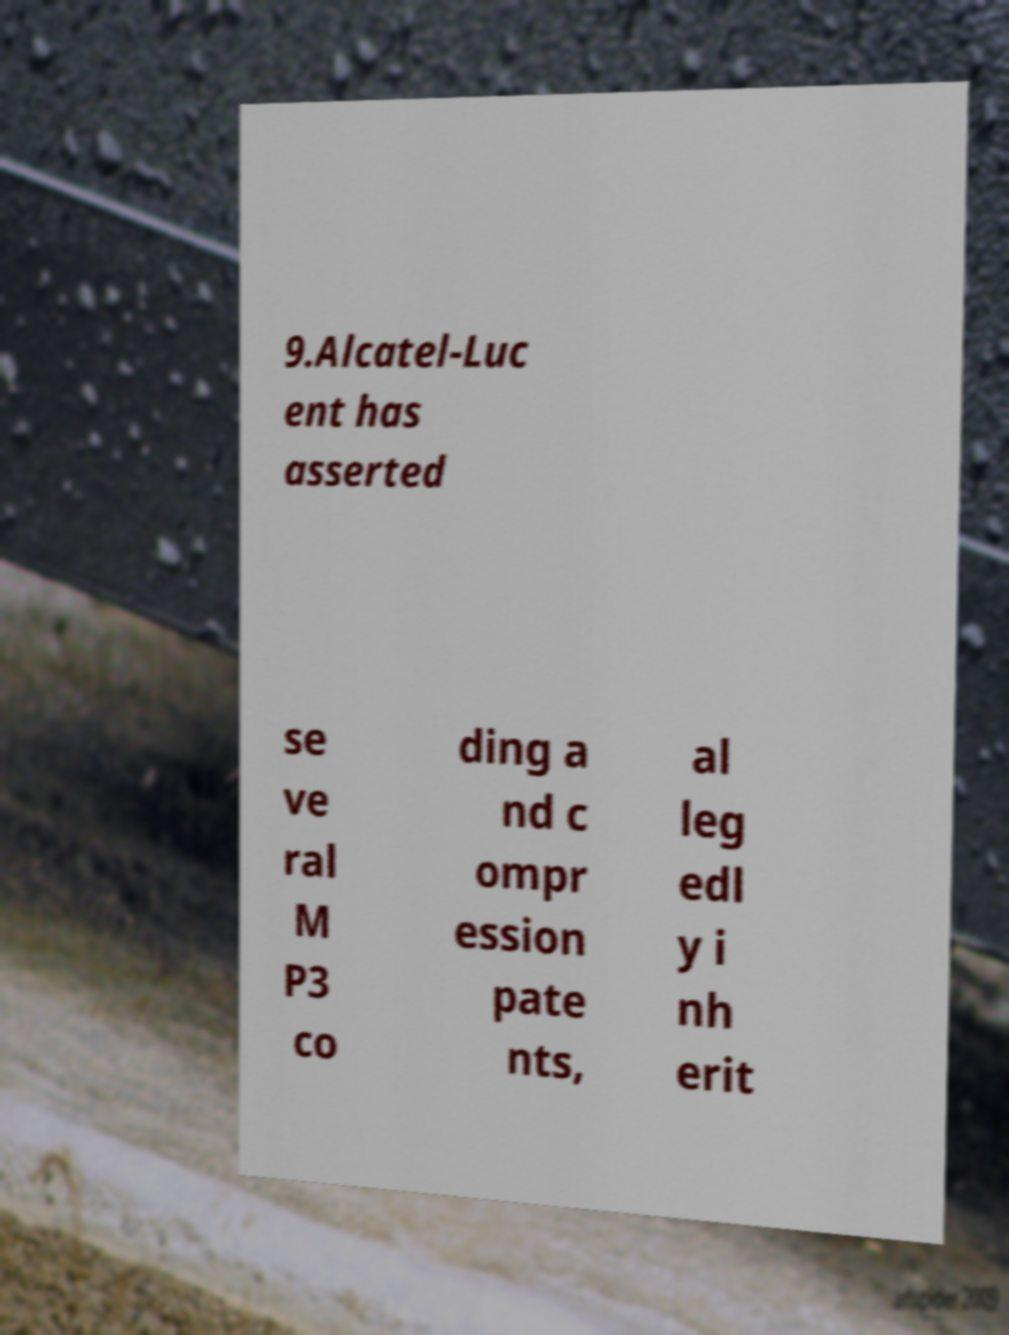What messages or text are displayed in this image? I need them in a readable, typed format. 9.Alcatel-Luc ent has asserted se ve ral M P3 co ding a nd c ompr ession pate nts, al leg edl y i nh erit 